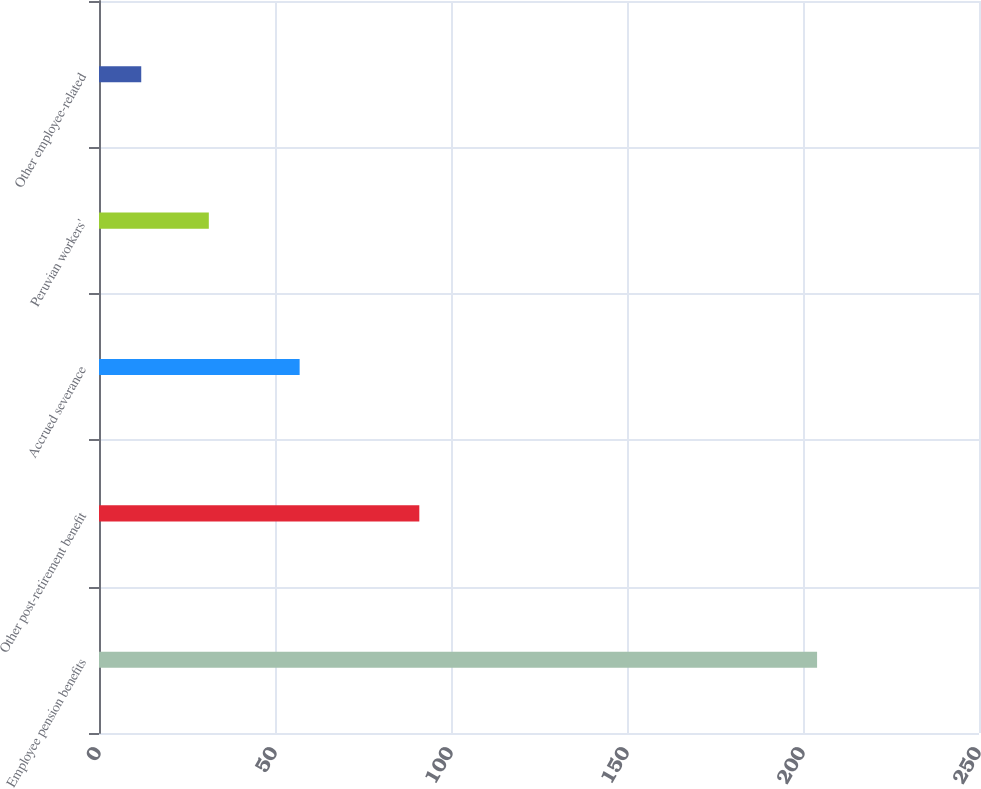Convert chart. <chart><loc_0><loc_0><loc_500><loc_500><bar_chart><fcel>Employee pension benefits<fcel>Other post-retirement benefit<fcel>Accrued severance<fcel>Peruvian workers'<fcel>Other employee-related<nl><fcel>204<fcel>91<fcel>57<fcel>31.2<fcel>12<nl></chart> 